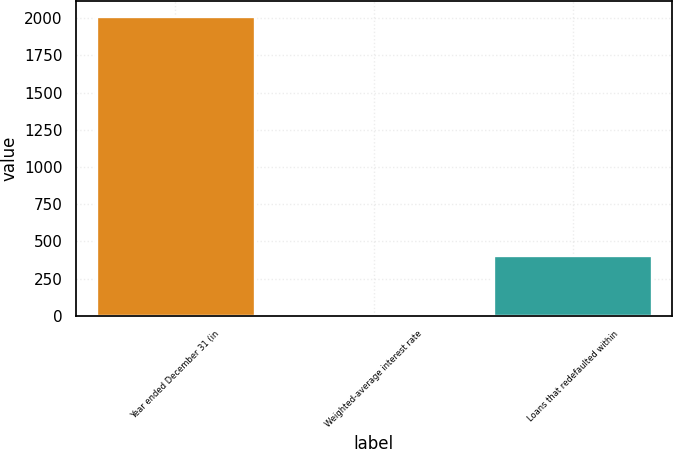Convert chart to OTSL. <chart><loc_0><loc_0><loc_500><loc_500><bar_chart><fcel>Year ended December 31 (in<fcel>Weighted-average interest rate<fcel>Loans that redefaulted within<nl><fcel>2018<fcel>5.16<fcel>407.72<nl></chart> 